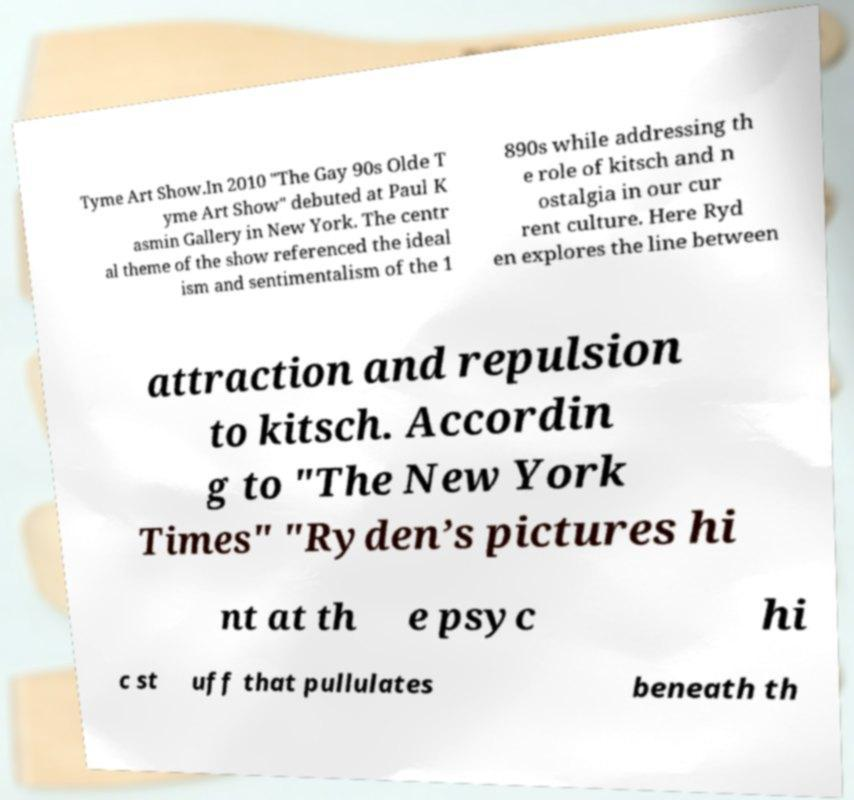Please read and relay the text visible in this image. What does it say? Tyme Art Show.In 2010 "The Gay 90s Olde T yme Art Show" debuted at Paul K asmin Gallery in New York. The centr al theme of the show referenced the ideal ism and sentimentalism of the 1 890s while addressing th e role of kitsch and n ostalgia in our cur rent culture. Here Ryd en explores the line between attraction and repulsion to kitsch. Accordin g to "The New York Times" "Ryden’s pictures hi nt at th e psyc hi c st uff that pullulates beneath th 